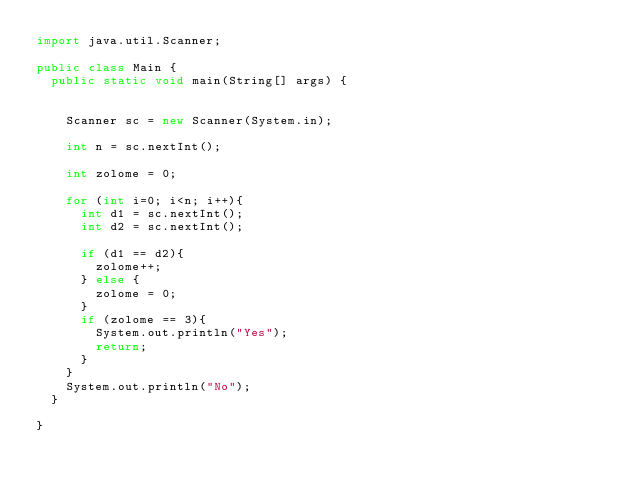<code> <loc_0><loc_0><loc_500><loc_500><_Java_>import java.util.Scanner;

public class Main {
	public static void main(String[] args) {


		Scanner sc = new Scanner(System.in);

		int n = sc.nextInt();

		int zolome = 0;

		for (int i=0; i<n; i++){
			int d1 = sc.nextInt();
			int d2 = sc.nextInt();

			if (d1 == d2){
				zolome++;
			} else {
				zolome = 0;
			}
			if (zolome == 3){
				System.out.println("Yes");
				return;
			}
		}
		System.out.println("No");
	}

}</code> 